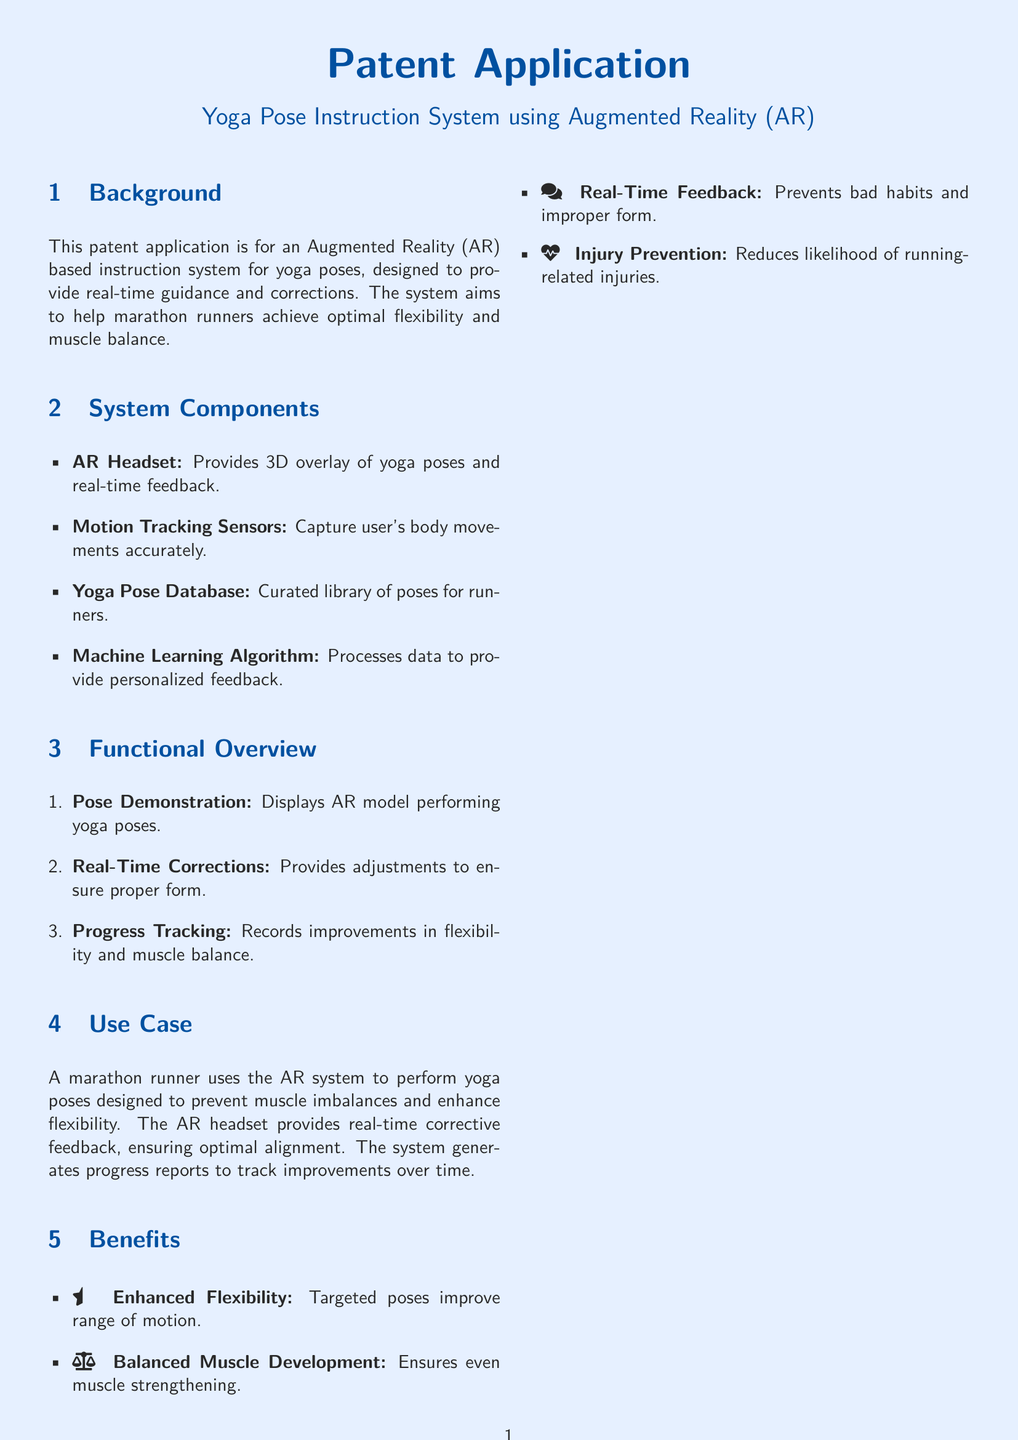What is the title of the patent? The title is explicitly stated at the beginning of the document.
Answer: Yoga Pose Instruction System using Augmented Reality (AR) What kind of headset does the system use? The document specifies the type of headset used in the system.
Answer: AR Headset What is included in the yoga pose database? The document mentions a specific component regarding the yoga pose collection.
Answer: Curated library of poses for runners What type of algorithm does the system use? The document describes the kind of algorithm utilized in the system functionalities.
Answer: Machine Learning Algorithm What is one benefit of the system? The document enumerates benefits in a list format.
Answer: Enhanced Flexibility What does the progress tracking feature record? The document highlights the tracking functionality and its focus area.
Answer: Improvements in flexibility and muscle balance How does the system provide feedback? The document outlines the method of feedback delivery within the system.
Answer: Real-Time Corrections Which group is the system primarily designed for? The document specifies the target audience for the AR system in its use case.
Answer: Marathon runners 